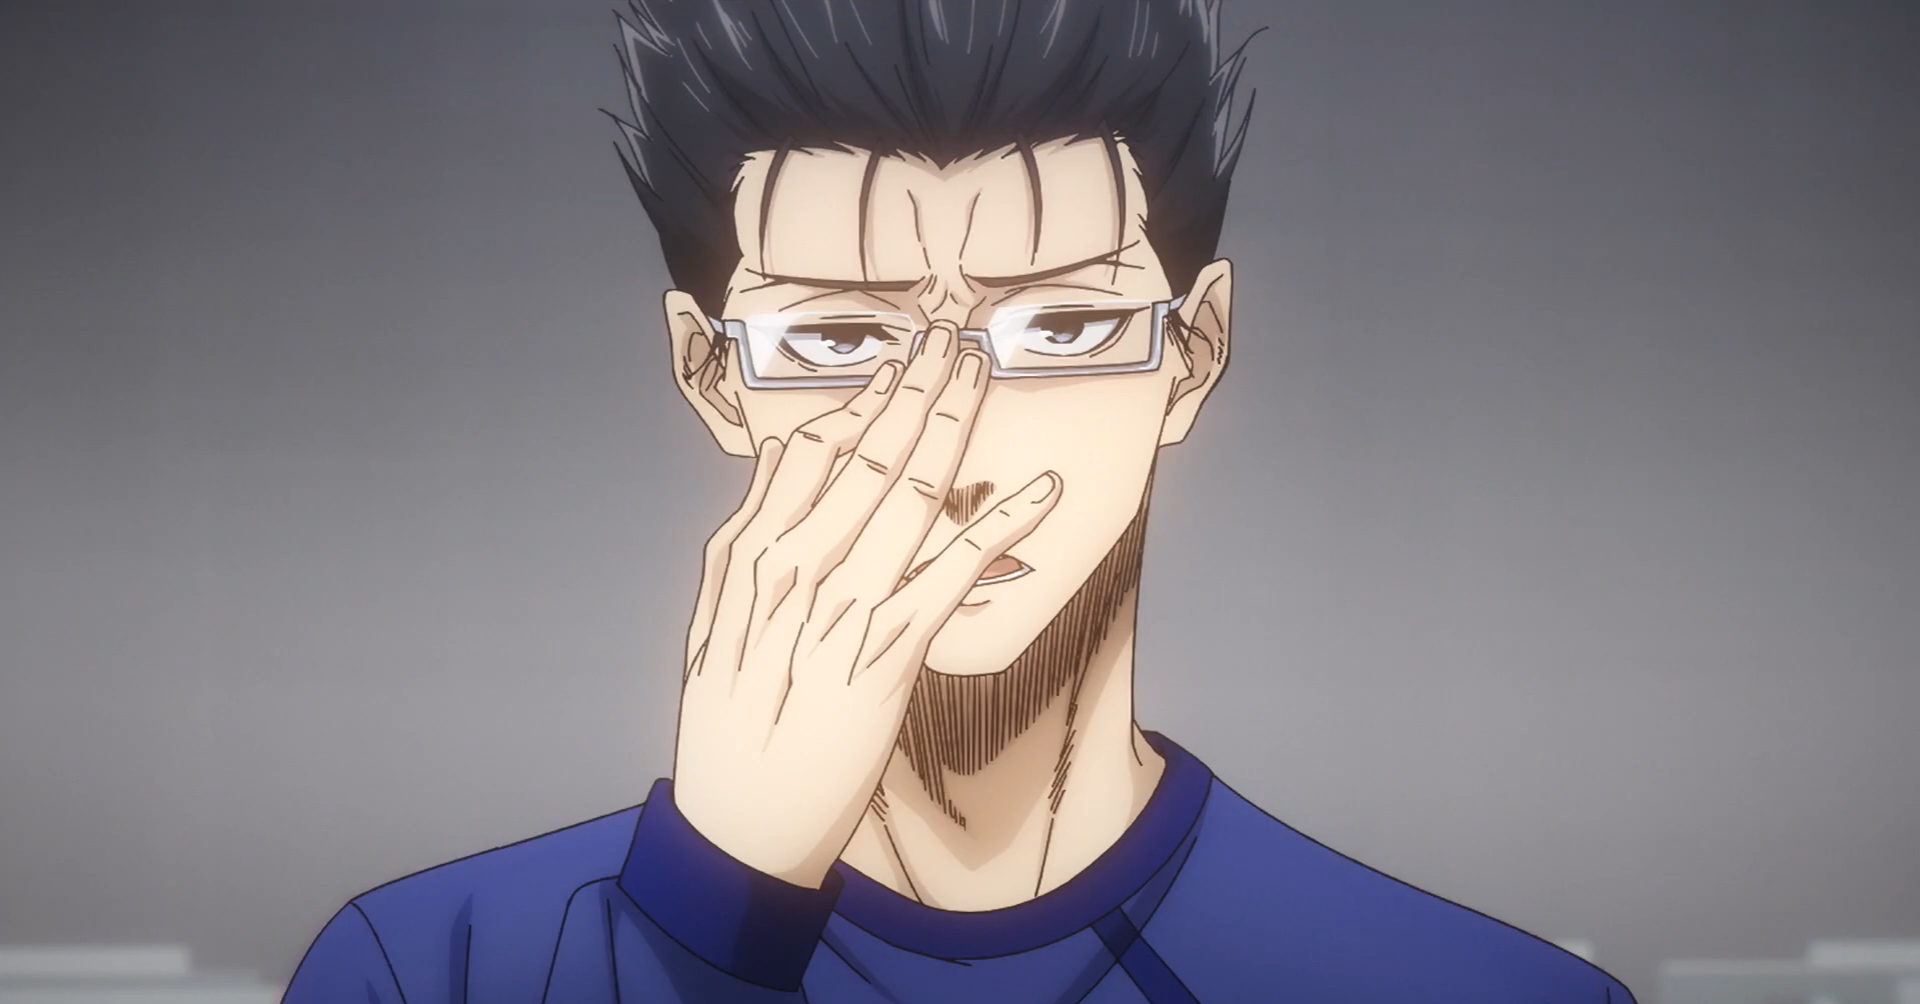make it in blade runner 2049 style Here is the image you requested in the style of Blade Runner 2049. 